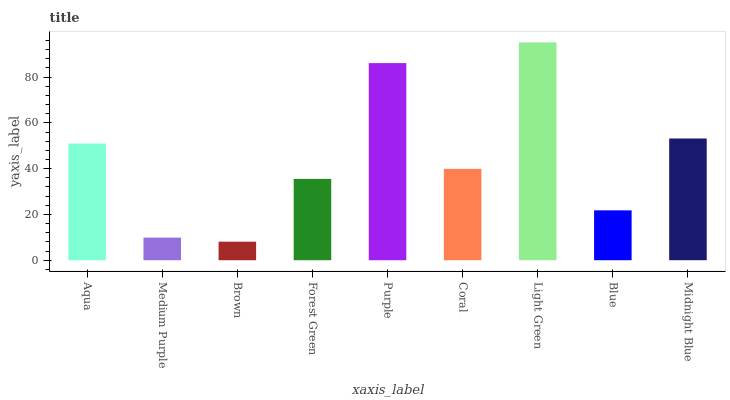Is Brown the minimum?
Answer yes or no. Yes. Is Light Green the maximum?
Answer yes or no. Yes. Is Medium Purple the minimum?
Answer yes or no. No. Is Medium Purple the maximum?
Answer yes or no. No. Is Aqua greater than Medium Purple?
Answer yes or no. Yes. Is Medium Purple less than Aqua?
Answer yes or no. Yes. Is Medium Purple greater than Aqua?
Answer yes or no. No. Is Aqua less than Medium Purple?
Answer yes or no. No. Is Coral the high median?
Answer yes or no. Yes. Is Coral the low median?
Answer yes or no. Yes. Is Purple the high median?
Answer yes or no. No. Is Aqua the low median?
Answer yes or no. No. 